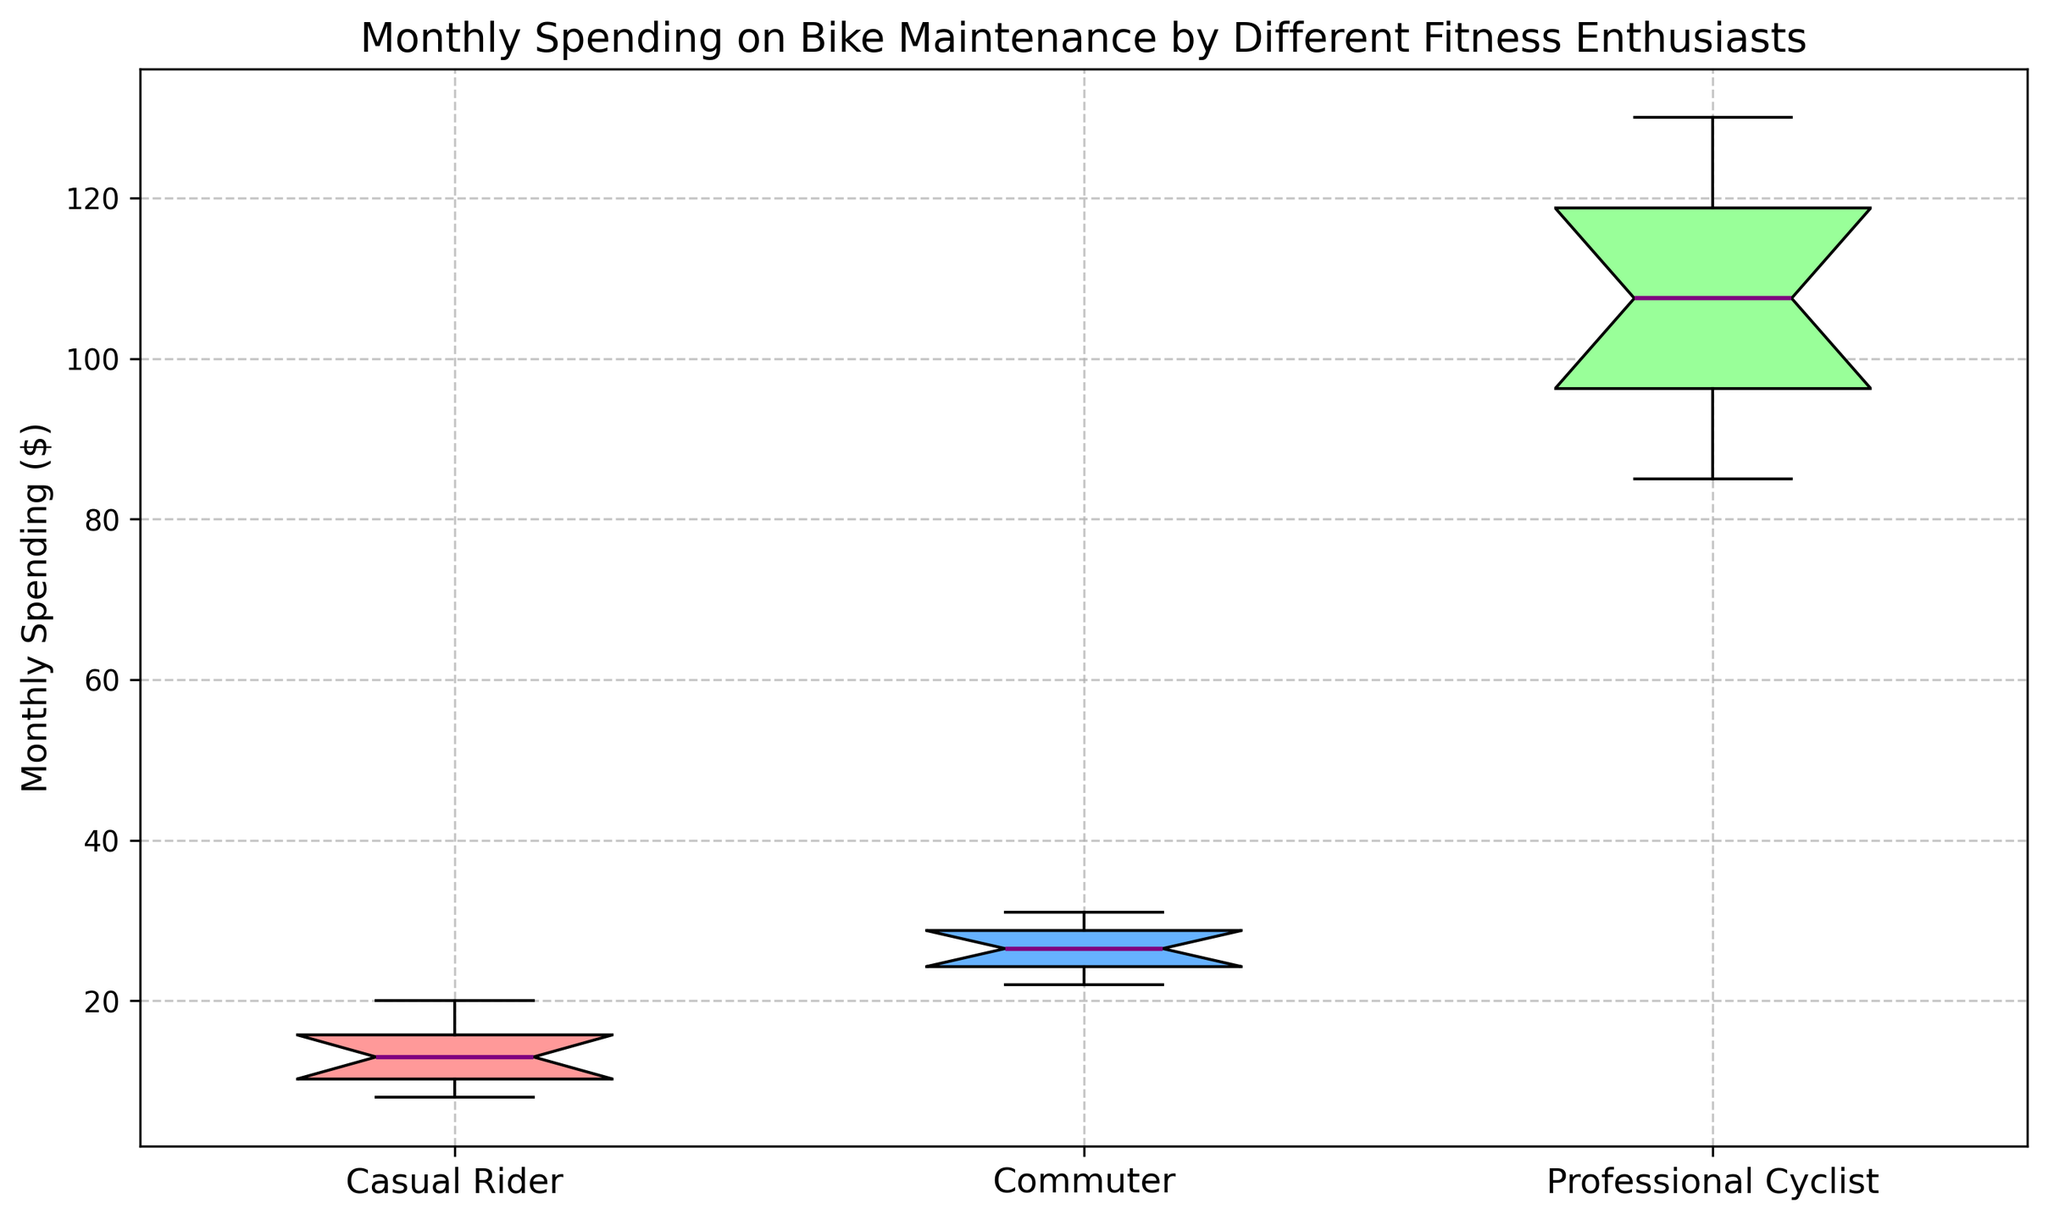What's the median monthly spending for Commuters? To find the median monthly spending for Commuters, look at the line in the center of the box for the Commuters category. The median is indicated by this line.
Answer: 26 Which group has the highest median monthly spending? Compare the medians (center lines of each box) for all the categories. The group with the highest median will have their center line higher than others.
Answer: Professional Cyclists Is the spending range for Casual Riders smaller or larger than for Commuters? Look at the length of the boxes which represents the interquartile range (IQR). The IQR for Casual Riders is visibly shorter than the IQR for Commuters. The spending range for Casual Riders is smaller.
Answer: Smaller What is the interquartile range (IQR) for Professional Cyclists? The IQR is the distance between the first quartile (bottom of the box) and the third quartile (top of the box). For Professional Cyclists, measured from around 95 to 120. 120 - 95 = 25
Answer: 25 Which group has the widest range of monthly spending? Range refers to the difference between the smallest and largest values. Find the group with the highest spread in the whiskers (the lines extending from the box). Professional Cyclists show the widest range.
Answer: Professional Cyclists How does the median monthly spending of Professional Cyclists compare to Casual Riders? Compare the median lines of both boxes. The median spending of Professional Cyclists is significantly higher than that of Casual Riders.
Answer: Higher Which group has the least variation in their monthly spending? Variation can be observed from the width of the IQR (the box length). The group with the shortest box has the least variation. Casual Riders have the shortest box.
Answer: Casual Riders What's the maximum monthly spending recorded for Commuters? The maximum value is indicated by the top whisker extending from the box. For Commuters, this is the line at the top whisker of around 31.
Answer: 31 Compare the median spending of Commuters and Professional Cyclists. By how much do they differ? Check the medians of both groups and subtract the median of Commuters from the median of Professional Cyclists. Median of Professional Cyclists is around 107.5, and Commuters is 26. Difference = 107.5 - 26 = 81.5
Answer: 81.5 What colors represent Casual Riders, Commuters, and Professional Cyclists in the plot? Identify the colors of the boxes: Casual Riders are pink/red, Commuters are blue, and Professional Cyclists are green.
Answer: Pink/red, Blue, Green 